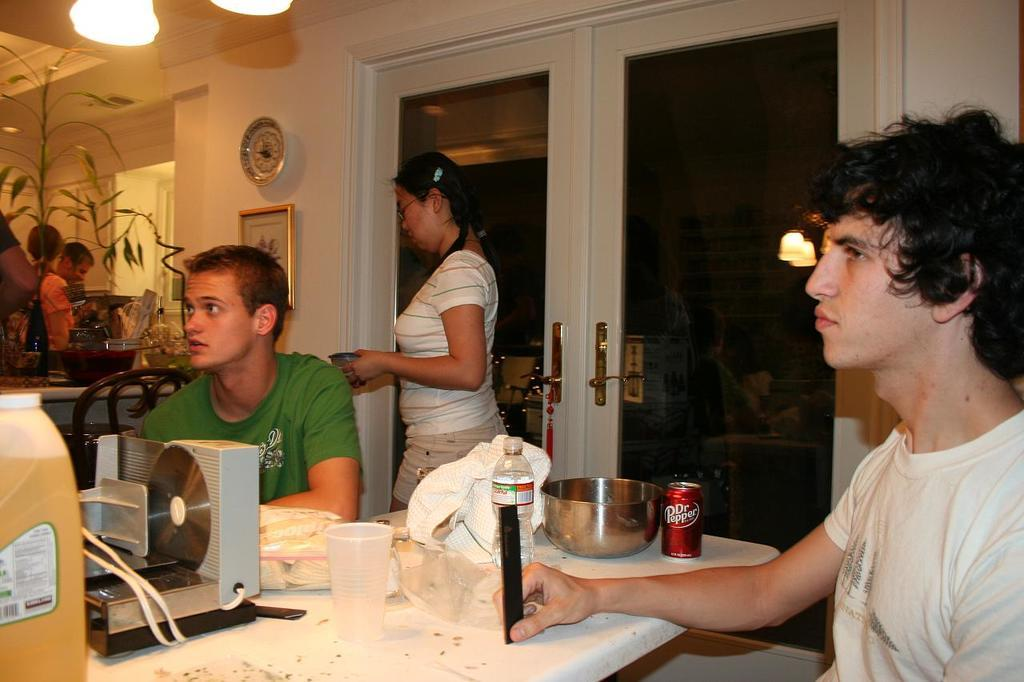How many boys are in the image? There are two boys in the image. What are the boys doing in the image? The boys are sitting on a table and looking to the left. Who else is present in the image besides the boys? There is a girl in the image. What is the girl doing in the image? The girl is walking. What can be seen in the background of the image? There is a glass door in the image. What type of salt can be seen on the table in the image? There is no salt present on the table in the image. What is the girl carrying in the image? The girl is walking, but there is no mention of her carrying anything in the provided facts. --- Facts: 1. There is a car in the image. 2. The car is red. 3. The car has four wheels. 4. There is a road in the image. 5. The road is paved. Absurd Topics: bird, ocean, mountain Conversation: What is the main subject of the image? The main subject of the image is a car. What color is the car? The car is red. How many wheels does the car have? The car has four wheels. What can be seen in the background of the image? There is a road in the image. What is the condition of the road? The road is paved. Reasoning: Let's think step by step in order to produce the conversation. We start by identifying the main subject of the image, which is the car. Then, we describe the car's color and the number of wheels it has. Next, we mention the presence of the road in the background and its condition. Each question is designed to elicit a specific detail about the image that is known from the provided facts. Absurd Question/Answer: Can you see any birds flying over the ocean in the image? There is no mention of birds, an ocean, or a mountain in the provided facts, so we cannot answer this question based on the image. 